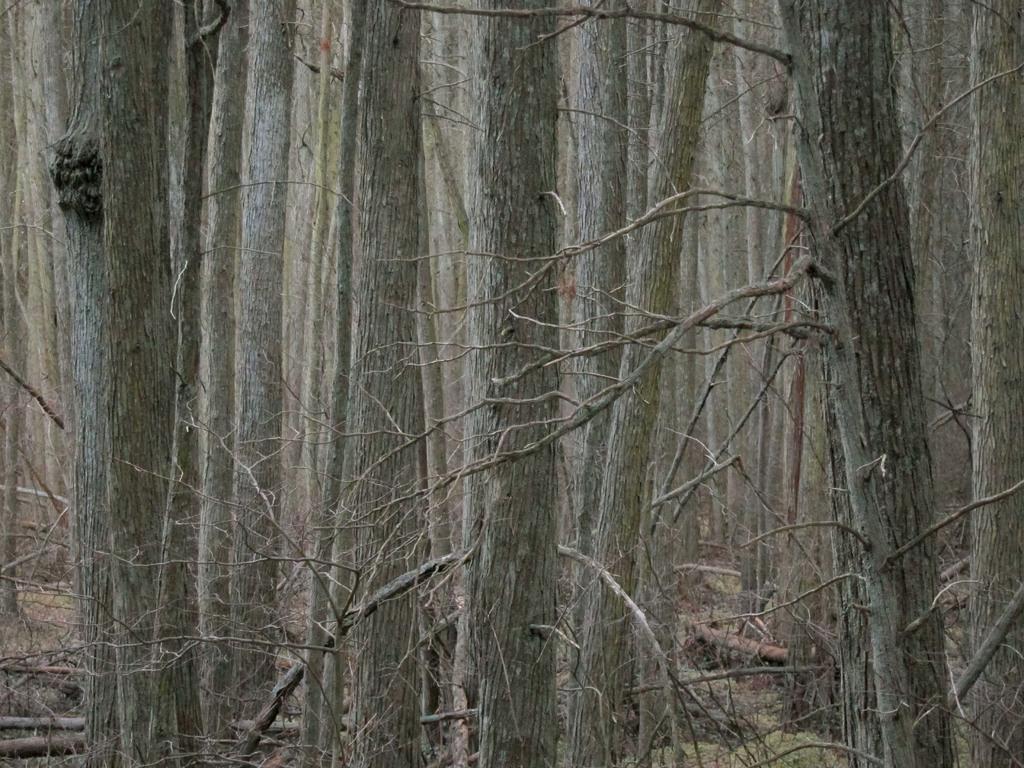Can you describe this image briefly? In this image we can see so many trees. 